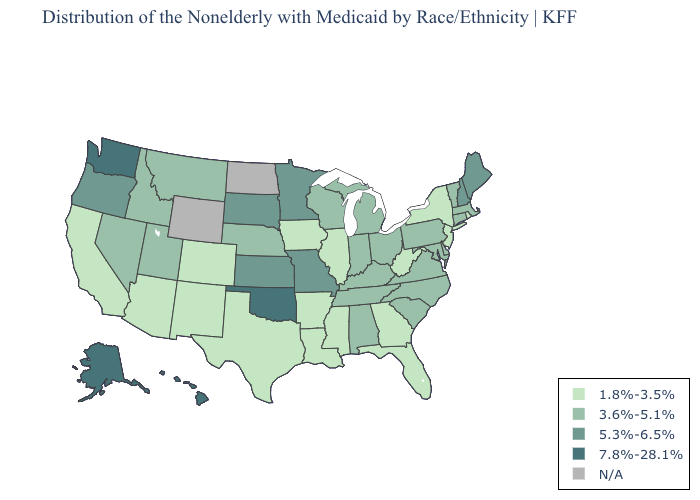What is the value of Texas?
Answer briefly. 1.8%-3.5%. Among the states that border Oklahoma , which have the lowest value?
Short answer required. Arkansas, Colorado, New Mexico, Texas. Does Louisiana have the lowest value in the USA?
Short answer required. Yes. Name the states that have a value in the range 7.8%-28.1%?
Short answer required. Alaska, Hawaii, Oklahoma, Washington. What is the value of Texas?
Keep it brief. 1.8%-3.5%. Which states have the lowest value in the USA?
Quick response, please. Arizona, Arkansas, California, Colorado, Florida, Georgia, Illinois, Iowa, Louisiana, Mississippi, New Jersey, New Mexico, New York, Rhode Island, Texas, West Virginia. What is the value of Alabama?
Answer briefly. 3.6%-5.1%. Which states have the highest value in the USA?
Write a very short answer. Alaska, Hawaii, Oklahoma, Washington. What is the value of Michigan?
Quick response, please. 3.6%-5.1%. Name the states that have a value in the range 5.3%-6.5%?
Keep it brief. Kansas, Maine, Minnesota, Missouri, New Hampshire, Oregon, South Dakota. Which states hav the highest value in the Northeast?
Write a very short answer. Maine, New Hampshire. What is the value of South Dakota?
Give a very brief answer. 5.3%-6.5%. What is the value of Iowa?
Answer briefly. 1.8%-3.5%. Name the states that have a value in the range 1.8%-3.5%?
Answer briefly. Arizona, Arkansas, California, Colorado, Florida, Georgia, Illinois, Iowa, Louisiana, Mississippi, New Jersey, New Mexico, New York, Rhode Island, Texas, West Virginia. 